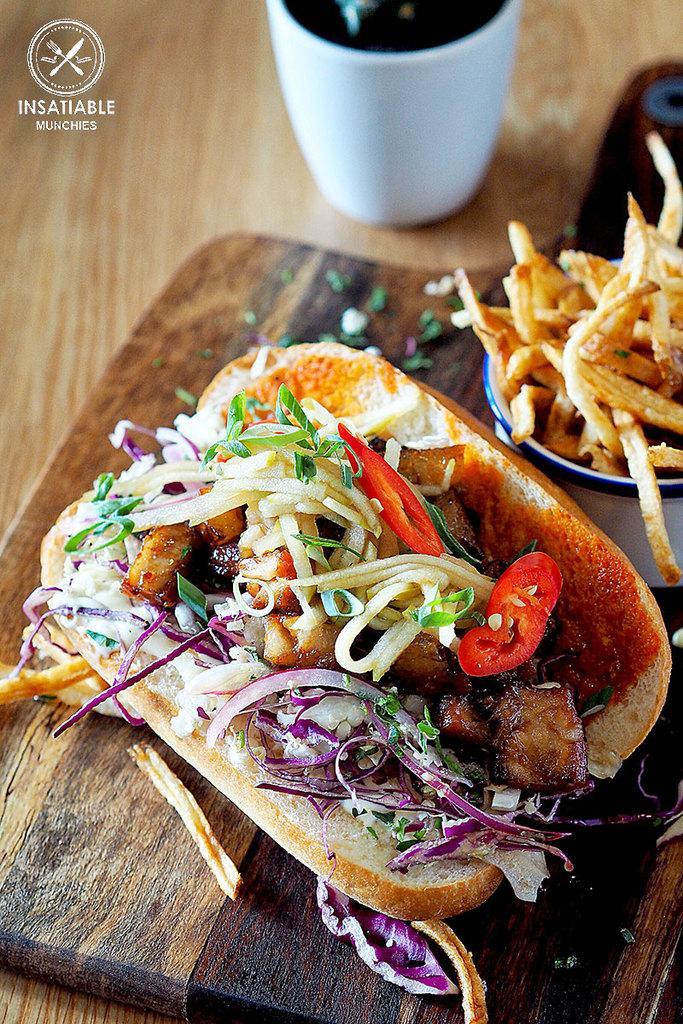What type of surface is the food placed on in the image? The food items are placed on a wooden surface in the image. What type of container is visible in the image? There is a mug in the image. Where is the text located in the image? The text is in the top left corner of the image. What type of eggnog is being served in the mug in the image? There is no eggnog present in the image; it only shows a mug and food items on a wooden surface. 